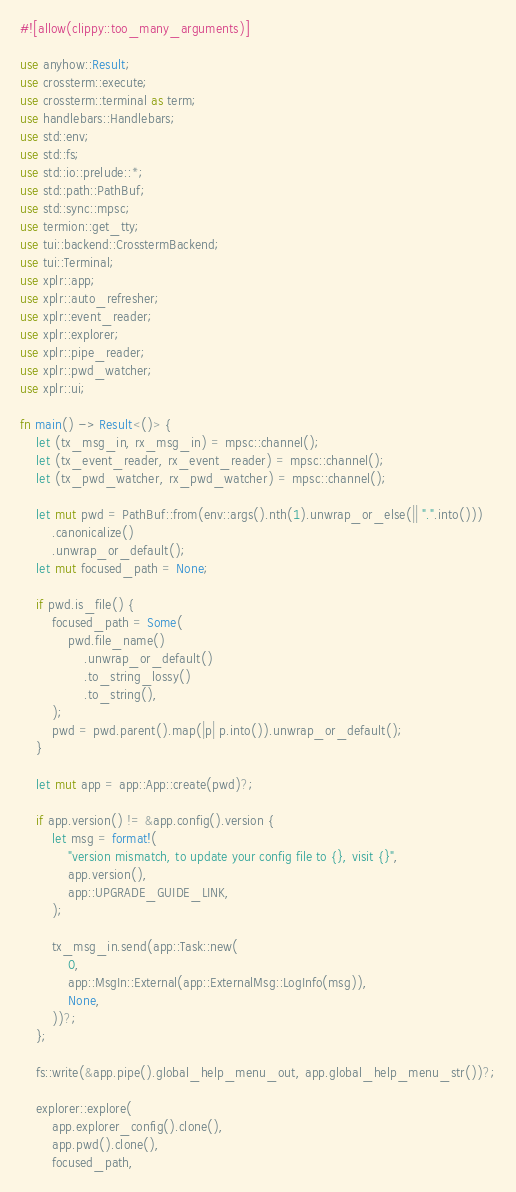<code> <loc_0><loc_0><loc_500><loc_500><_Rust_>#![allow(clippy::too_many_arguments)]

use anyhow::Result;
use crossterm::execute;
use crossterm::terminal as term;
use handlebars::Handlebars;
use std::env;
use std::fs;
use std::io::prelude::*;
use std::path::PathBuf;
use std::sync::mpsc;
use termion::get_tty;
use tui::backend::CrosstermBackend;
use tui::Terminal;
use xplr::app;
use xplr::auto_refresher;
use xplr::event_reader;
use xplr::explorer;
use xplr::pipe_reader;
use xplr::pwd_watcher;
use xplr::ui;

fn main() -> Result<()> {
    let (tx_msg_in, rx_msg_in) = mpsc::channel();
    let (tx_event_reader, rx_event_reader) = mpsc::channel();
    let (tx_pwd_watcher, rx_pwd_watcher) = mpsc::channel();

    let mut pwd = PathBuf::from(env::args().nth(1).unwrap_or_else(|| ".".into()))
        .canonicalize()
        .unwrap_or_default();
    let mut focused_path = None;

    if pwd.is_file() {
        focused_path = Some(
            pwd.file_name()
                .unwrap_or_default()
                .to_string_lossy()
                .to_string(),
        );
        pwd = pwd.parent().map(|p| p.into()).unwrap_or_default();
    }

    let mut app = app::App::create(pwd)?;

    if app.version() != &app.config().version {
        let msg = format!(
            "version mismatch, to update your config file to {}, visit {}",
            app.version(),
            app::UPGRADE_GUIDE_LINK,
        );

        tx_msg_in.send(app::Task::new(
            0,
            app::MsgIn::External(app::ExternalMsg::LogInfo(msg)),
            None,
        ))?;
    };

    fs::write(&app.pipe().global_help_menu_out, app.global_help_menu_str())?;

    explorer::explore(
        app.explorer_config().clone(),
        app.pwd().clone(),
        focused_path,</code> 